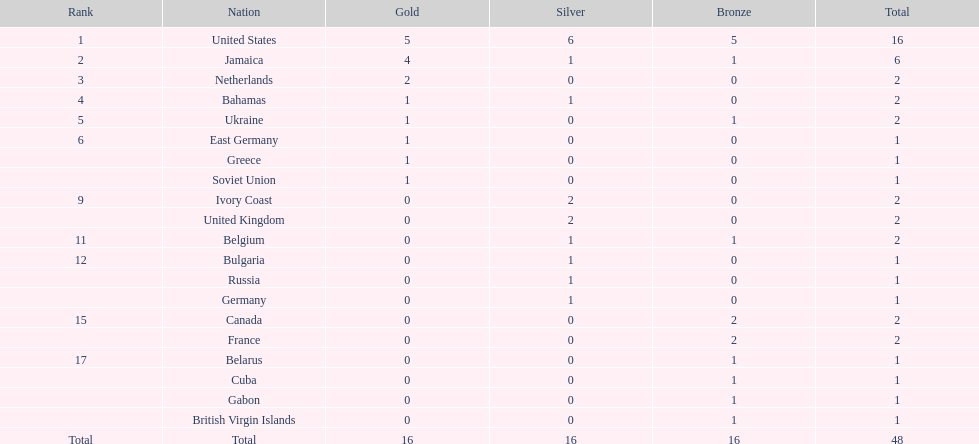Among the top 5 countries, what is the typical quantity of gold medals earned? 2.6. 